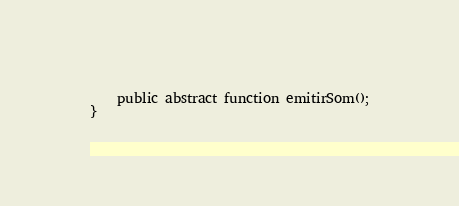Convert code to text. <code><loc_0><loc_0><loc_500><loc_500><_PHP_>    public abstract function emitirSom();
}</code> 